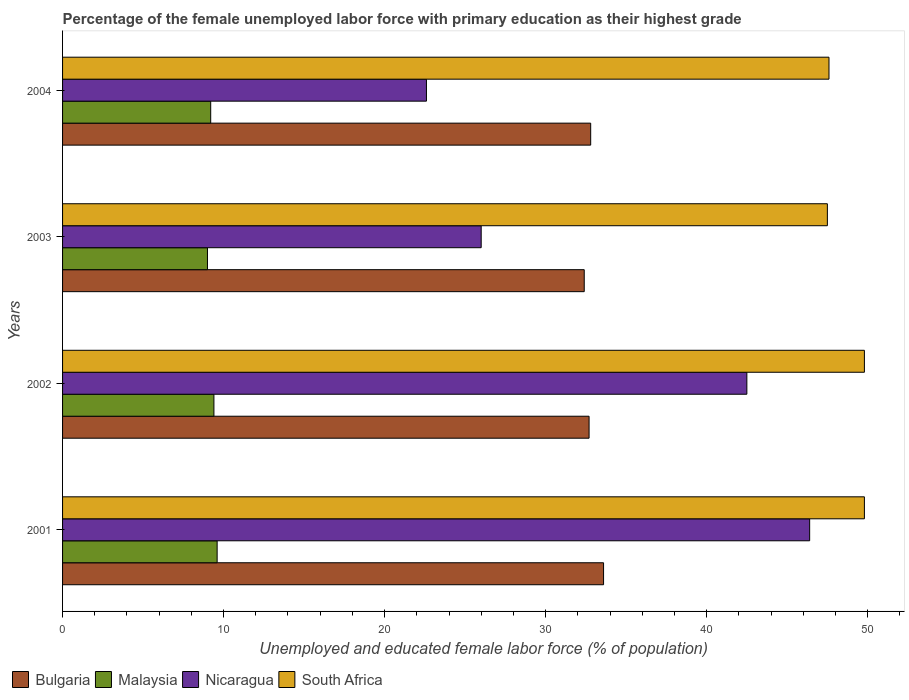How many different coloured bars are there?
Give a very brief answer. 4. How many groups of bars are there?
Offer a very short reply. 4. Are the number of bars per tick equal to the number of legend labels?
Offer a very short reply. Yes. Are the number of bars on each tick of the Y-axis equal?
Ensure brevity in your answer.  Yes. How many bars are there on the 2nd tick from the top?
Offer a very short reply. 4. How many bars are there on the 2nd tick from the bottom?
Your answer should be very brief. 4. In how many cases, is the number of bars for a given year not equal to the number of legend labels?
Provide a succinct answer. 0. What is the percentage of the unemployed female labor force with primary education in Bulgaria in 2004?
Your response must be concise. 32.8. Across all years, what is the maximum percentage of the unemployed female labor force with primary education in Malaysia?
Make the answer very short. 9.6. Across all years, what is the minimum percentage of the unemployed female labor force with primary education in Bulgaria?
Make the answer very short. 32.4. In which year was the percentage of the unemployed female labor force with primary education in Bulgaria maximum?
Offer a very short reply. 2001. In which year was the percentage of the unemployed female labor force with primary education in South Africa minimum?
Keep it short and to the point. 2003. What is the total percentage of the unemployed female labor force with primary education in South Africa in the graph?
Your answer should be very brief. 194.7. What is the difference between the percentage of the unemployed female labor force with primary education in South Africa in 2002 and that in 2004?
Your response must be concise. 2.2. What is the difference between the percentage of the unemployed female labor force with primary education in Bulgaria in 2001 and the percentage of the unemployed female labor force with primary education in Nicaragua in 2003?
Provide a short and direct response. 7.6. What is the average percentage of the unemployed female labor force with primary education in Bulgaria per year?
Provide a succinct answer. 32.88. In the year 2004, what is the difference between the percentage of the unemployed female labor force with primary education in Bulgaria and percentage of the unemployed female labor force with primary education in South Africa?
Provide a short and direct response. -14.8. In how many years, is the percentage of the unemployed female labor force with primary education in Nicaragua greater than 6 %?
Provide a short and direct response. 4. What is the ratio of the percentage of the unemployed female labor force with primary education in Nicaragua in 2001 to that in 2003?
Your answer should be very brief. 1.78. What is the difference between the highest and the second highest percentage of the unemployed female labor force with primary education in Bulgaria?
Your answer should be very brief. 0.8. What is the difference between the highest and the lowest percentage of the unemployed female labor force with primary education in Bulgaria?
Keep it short and to the point. 1.2. Is the sum of the percentage of the unemployed female labor force with primary education in Bulgaria in 2003 and 2004 greater than the maximum percentage of the unemployed female labor force with primary education in South Africa across all years?
Keep it short and to the point. Yes. Is it the case that in every year, the sum of the percentage of the unemployed female labor force with primary education in Bulgaria and percentage of the unemployed female labor force with primary education in Malaysia is greater than the sum of percentage of the unemployed female labor force with primary education in Nicaragua and percentage of the unemployed female labor force with primary education in South Africa?
Offer a very short reply. No. What does the 2nd bar from the bottom in 2004 represents?
Give a very brief answer. Malaysia. Is it the case that in every year, the sum of the percentage of the unemployed female labor force with primary education in Nicaragua and percentage of the unemployed female labor force with primary education in Bulgaria is greater than the percentage of the unemployed female labor force with primary education in Malaysia?
Keep it short and to the point. Yes. Are all the bars in the graph horizontal?
Your response must be concise. Yes. What is the difference between two consecutive major ticks on the X-axis?
Your answer should be compact. 10. How are the legend labels stacked?
Give a very brief answer. Horizontal. What is the title of the graph?
Your answer should be very brief. Percentage of the female unemployed labor force with primary education as their highest grade. What is the label or title of the X-axis?
Provide a short and direct response. Unemployed and educated female labor force (% of population). What is the label or title of the Y-axis?
Offer a very short reply. Years. What is the Unemployed and educated female labor force (% of population) of Bulgaria in 2001?
Ensure brevity in your answer.  33.6. What is the Unemployed and educated female labor force (% of population) in Malaysia in 2001?
Offer a very short reply. 9.6. What is the Unemployed and educated female labor force (% of population) in Nicaragua in 2001?
Provide a short and direct response. 46.4. What is the Unemployed and educated female labor force (% of population) of South Africa in 2001?
Your answer should be compact. 49.8. What is the Unemployed and educated female labor force (% of population) in Bulgaria in 2002?
Provide a short and direct response. 32.7. What is the Unemployed and educated female labor force (% of population) of Malaysia in 2002?
Your answer should be very brief. 9.4. What is the Unemployed and educated female labor force (% of population) in Nicaragua in 2002?
Your answer should be compact. 42.5. What is the Unemployed and educated female labor force (% of population) of South Africa in 2002?
Keep it short and to the point. 49.8. What is the Unemployed and educated female labor force (% of population) of Bulgaria in 2003?
Offer a terse response. 32.4. What is the Unemployed and educated female labor force (% of population) of Malaysia in 2003?
Your answer should be very brief. 9. What is the Unemployed and educated female labor force (% of population) in South Africa in 2003?
Offer a terse response. 47.5. What is the Unemployed and educated female labor force (% of population) in Bulgaria in 2004?
Ensure brevity in your answer.  32.8. What is the Unemployed and educated female labor force (% of population) of Malaysia in 2004?
Your answer should be very brief. 9.2. What is the Unemployed and educated female labor force (% of population) in Nicaragua in 2004?
Offer a very short reply. 22.6. What is the Unemployed and educated female labor force (% of population) in South Africa in 2004?
Give a very brief answer. 47.6. Across all years, what is the maximum Unemployed and educated female labor force (% of population) in Bulgaria?
Offer a very short reply. 33.6. Across all years, what is the maximum Unemployed and educated female labor force (% of population) in Malaysia?
Ensure brevity in your answer.  9.6. Across all years, what is the maximum Unemployed and educated female labor force (% of population) in Nicaragua?
Your response must be concise. 46.4. Across all years, what is the maximum Unemployed and educated female labor force (% of population) in South Africa?
Give a very brief answer. 49.8. Across all years, what is the minimum Unemployed and educated female labor force (% of population) of Bulgaria?
Provide a short and direct response. 32.4. Across all years, what is the minimum Unemployed and educated female labor force (% of population) in Nicaragua?
Make the answer very short. 22.6. Across all years, what is the minimum Unemployed and educated female labor force (% of population) in South Africa?
Keep it short and to the point. 47.5. What is the total Unemployed and educated female labor force (% of population) in Bulgaria in the graph?
Ensure brevity in your answer.  131.5. What is the total Unemployed and educated female labor force (% of population) of Malaysia in the graph?
Your answer should be compact. 37.2. What is the total Unemployed and educated female labor force (% of population) in Nicaragua in the graph?
Offer a very short reply. 137.5. What is the total Unemployed and educated female labor force (% of population) of South Africa in the graph?
Give a very brief answer. 194.7. What is the difference between the Unemployed and educated female labor force (% of population) of Malaysia in 2001 and that in 2002?
Offer a very short reply. 0.2. What is the difference between the Unemployed and educated female labor force (% of population) in Nicaragua in 2001 and that in 2003?
Offer a very short reply. 20.4. What is the difference between the Unemployed and educated female labor force (% of population) in Nicaragua in 2001 and that in 2004?
Your response must be concise. 23.8. What is the difference between the Unemployed and educated female labor force (% of population) of Malaysia in 2002 and that in 2004?
Your response must be concise. 0.2. What is the difference between the Unemployed and educated female labor force (% of population) in Malaysia in 2003 and that in 2004?
Ensure brevity in your answer.  -0.2. What is the difference between the Unemployed and educated female labor force (% of population) in South Africa in 2003 and that in 2004?
Keep it short and to the point. -0.1. What is the difference between the Unemployed and educated female labor force (% of population) of Bulgaria in 2001 and the Unemployed and educated female labor force (% of population) of Malaysia in 2002?
Make the answer very short. 24.2. What is the difference between the Unemployed and educated female labor force (% of population) in Bulgaria in 2001 and the Unemployed and educated female labor force (% of population) in South Africa in 2002?
Provide a succinct answer. -16.2. What is the difference between the Unemployed and educated female labor force (% of population) in Malaysia in 2001 and the Unemployed and educated female labor force (% of population) in Nicaragua in 2002?
Provide a short and direct response. -32.9. What is the difference between the Unemployed and educated female labor force (% of population) in Malaysia in 2001 and the Unemployed and educated female labor force (% of population) in South Africa in 2002?
Your response must be concise. -40.2. What is the difference between the Unemployed and educated female labor force (% of population) of Nicaragua in 2001 and the Unemployed and educated female labor force (% of population) of South Africa in 2002?
Give a very brief answer. -3.4. What is the difference between the Unemployed and educated female labor force (% of population) of Bulgaria in 2001 and the Unemployed and educated female labor force (% of population) of Malaysia in 2003?
Your answer should be very brief. 24.6. What is the difference between the Unemployed and educated female labor force (% of population) of Bulgaria in 2001 and the Unemployed and educated female labor force (% of population) of South Africa in 2003?
Make the answer very short. -13.9. What is the difference between the Unemployed and educated female labor force (% of population) of Malaysia in 2001 and the Unemployed and educated female labor force (% of population) of Nicaragua in 2003?
Provide a short and direct response. -16.4. What is the difference between the Unemployed and educated female labor force (% of population) of Malaysia in 2001 and the Unemployed and educated female labor force (% of population) of South Africa in 2003?
Give a very brief answer. -37.9. What is the difference between the Unemployed and educated female labor force (% of population) of Nicaragua in 2001 and the Unemployed and educated female labor force (% of population) of South Africa in 2003?
Make the answer very short. -1.1. What is the difference between the Unemployed and educated female labor force (% of population) of Bulgaria in 2001 and the Unemployed and educated female labor force (% of population) of Malaysia in 2004?
Provide a short and direct response. 24.4. What is the difference between the Unemployed and educated female labor force (% of population) of Bulgaria in 2001 and the Unemployed and educated female labor force (% of population) of Nicaragua in 2004?
Keep it short and to the point. 11. What is the difference between the Unemployed and educated female labor force (% of population) of Malaysia in 2001 and the Unemployed and educated female labor force (% of population) of South Africa in 2004?
Offer a very short reply. -38. What is the difference between the Unemployed and educated female labor force (% of population) of Nicaragua in 2001 and the Unemployed and educated female labor force (% of population) of South Africa in 2004?
Make the answer very short. -1.2. What is the difference between the Unemployed and educated female labor force (% of population) of Bulgaria in 2002 and the Unemployed and educated female labor force (% of population) of Malaysia in 2003?
Ensure brevity in your answer.  23.7. What is the difference between the Unemployed and educated female labor force (% of population) in Bulgaria in 2002 and the Unemployed and educated female labor force (% of population) in Nicaragua in 2003?
Provide a succinct answer. 6.7. What is the difference between the Unemployed and educated female labor force (% of population) in Bulgaria in 2002 and the Unemployed and educated female labor force (% of population) in South Africa in 2003?
Offer a terse response. -14.8. What is the difference between the Unemployed and educated female labor force (% of population) of Malaysia in 2002 and the Unemployed and educated female labor force (% of population) of Nicaragua in 2003?
Ensure brevity in your answer.  -16.6. What is the difference between the Unemployed and educated female labor force (% of population) in Malaysia in 2002 and the Unemployed and educated female labor force (% of population) in South Africa in 2003?
Provide a succinct answer. -38.1. What is the difference between the Unemployed and educated female labor force (% of population) of Nicaragua in 2002 and the Unemployed and educated female labor force (% of population) of South Africa in 2003?
Your response must be concise. -5. What is the difference between the Unemployed and educated female labor force (% of population) of Bulgaria in 2002 and the Unemployed and educated female labor force (% of population) of Nicaragua in 2004?
Provide a succinct answer. 10.1. What is the difference between the Unemployed and educated female labor force (% of population) of Bulgaria in 2002 and the Unemployed and educated female labor force (% of population) of South Africa in 2004?
Provide a short and direct response. -14.9. What is the difference between the Unemployed and educated female labor force (% of population) of Malaysia in 2002 and the Unemployed and educated female labor force (% of population) of Nicaragua in 2004?
Your answer should be very brief. -13.2. What is the difference between the Unemployed and educated female labor force (% of population) of Malaysia in 2002 and the Unemployed and educated female labor force (% of population) of South Africa in 2004?
Your answer should be very brief. -38.2. What is the difference between the Unemployed and educated female labor force (% of population) of Nicaragua in 2002 and the Unemployed and educated female labor force (% of population) of South Africa in 2004?
Ensure brevity in your answer.  -5.1. What is the difference between the Unemployed and educated female labor force (% of population) of Bulgaria in 2003 and the Unemployed and educated female labor force (% of population) of Malaysia in 2004?
Ensure brevity in your answer.  23.2. What is the difference between the Unemployed and educated female labor force (% of population) of Bulgaria in 2003 and the Unemployed and educated female labor force (% of population) of Nicaragua in 2004?
Give a very brief answer. 9.8. What is the difference between the Unemployed and educated female labor force (% of population) of Bulgaria in 2003 and the Unemployed and educated female labor force (% of population) of South Africa in 2004?
Provide a succinct answer. -15.2. What is the difference between the Unemployed and educated female labor force (% of population) in Malaysia in 2003 and the Unemployed and educated female labor force (% of population) in Nicaragua in 2004?
Your answer should be compact. -13.6. What is the difference between the Unemployed and educated female labor force (% of population) in Malaysia in 2003 and the Unemployed and educated female labor force (% of population) in South Africa in 2004?
Provide a succinct answer. -38.6. What is the difference between the Unemployed and educated female labor force (% of population) of Nicaragua in 2003 and the Unemployed and educated female labor force (% of population) of South Africa in 2004?
Provide a succinct answer. -21.6. What is the average Unemployed and educated female labor force (% of population) of Bulgaria per year?
Offer a very short reply. 32.88. What is the average Unemployed and educated female labor force (% of population) in Nicaragua per year?
Offer a very short reply. 34.38. What is the average Unemployed and educated female labor force (% of population) in South Africa per year?
Offer a terse response. 48.67. In the year 2001, what is the difference between the Unemployed and educated female labor force (% of population) of Bulgaria and Unemployed and educated female labor force (% of population) of Malaysia?
Offer a very short reply. 24. In the year 2001, what is the difference between the Unemployed and educated female labor force (% of population) in Bulgaria and Unemployed and educated female labor force (% of population) in South Africa?
Keep it short and to the point. -16.2. In the year 2001, what is the difference between the Unemployed and educated female labor force (% of population) of Malaysia and Unemployed and educated female labor force (% of population) of Nicaragua?
Ensure brevity in your answer.  -36.8. In the year 2001, what is the difference between the Unemployed and educated female labor force (% of population) in Malaysia and Unemployed and educated female labor force (% of population) in South Africa?
Give a very brief answer. -40.2. In the year 2002, what is the difference between the Unemployed and educated female labor force (% of population) in Bulgaria and Unemployed and educated female labor force (% of population) in Malaysia?
Keep it short and to the point. 23.3. In the year 2002, what is the difference between the Unemployed and educated female labor force (% of population) in Bulgaria and Unemployed and educated female labor force (% of population) in South Africa?
Your answer should be very brief. -17.1. In the year 2002, what is the difference between the Unemployed and educated female labor force (% of population) of Malaysia and Unemployed and educated female labor force (% of population) of Nicaragua?
Keep it short and to the point. -33.1. In the year 2002, what is the difference between the Unemployed and educated female labor force (% of population) in Malaysia and Unemployed and educated female labor force (% of population) in South Africa?
Your answer should be compact. -40.4. In the year 2002, what is the difference between the Unemployed and educated female labor force (% of population) of Nicaragua and Unemployed and educated female labor force (% of population) of South Africa?
Offer a terse response. -7.3. In the year 2003, what is the difference between the Unemployed and educated female labor force (% of population) in Bulgaria and Unemployed and educated female labor force (% of population) in Malaysia?
Your response must be concise. 23.4. In the year 2003, what is the difference between the Unemployed and educated female labor force (% of population) of Bulgaria and Unemployed and educated female labor force (% of population) of Nicaragua?
Offer a terse response. 6.4. In the year 2003, what is the difference between the Unemployed and educated female labor force (% of population) of Bulgaria and Unemployed and educated female labor force (% of population) of South Africa?
Ensure brevity in your answer.  -15.1. In the year 2003, what is the difference between the Unemployed and educated female labor force (% of population) of Malaysia and Unemployed and educated female labor force (% of population) of Nicaragua?
Offer a very short reply. -17. In the year 2003, what is the difference between the Unemployed and educated female labor force (% of population) in Malaysia and Unemployed and educated female labor force (% of population) in South Africa?
Provide a succinct answer. -38.5. In the year 2003, what is the difference between the Unemployed and educated female labor force (% of population) of Nicaragua and Unemployed and educated female labor force (% of population) of South Africa?
Provide a short and direct response. -21.5. In the year 2004, what is the difference between the Unemployed and educated female labor force (% of population) of Bulgaria and Unemployed and educated female labor force (% of population) of Malaysia?
Your answer should be very brief. 23.6. In the year 2004, what is the difference between the Unemployed and educated female labor force (% of population) of Bulgaria and Unemployed and educated female labor force (% of population) of Nicaragua?
Your response must be concise. 10.2. In the year 2004, what is the difference between the Unemployed and educated female labor force (% of population) of Bulgaria and Unemployed and educated female labor force (% of population) of South Africa?
Make the answer very short. -14.8. In the year 2004, what is the difference between the Unemployed and educated female labor force (% of population) of Malaysia and Unemployed and educated female labor force (% of population) of South Africa?
Make the answer very short. -38.4. In the year 2004, what is the difference between the Unemployed and educated female labor force (% of population) in Nicaragua and Unemployed and educated female labor force (% of population) in South Africa?
Give a very brief answer. -25. What is the ratio of the Unemployed and educated female labor force (% of population) of Bulgaria in 2001 to that in 2002?
Provide a short and direct response. 1.03. What is the ratio of the Unemployed and educated female labor force (% of population) in Malaysia in 2001 to that in 2002?
Offer a very short reply. 1.02. What is the ratio of the Unemployed and educated female labor force (% of population) of Nicaragua in 2001 to that in 2002?
Ensure brevity in your answer.  1.09. What is the ratio of the Unemployed and educated female labor force (% of population) of Malaysia in 2001 to that in 2003?
Make the answer very short. 1.07. What is the ratio of the Unemployed and educated female labor force (% of population) in Nicaragua in 2001 to that in 2003?
Keep it short and to the point. 1.78. What is the ratio of the Unemployed and educated female labor force (% of population) of South Africa in 2001 to that in 2003?
Provide a succinct answer. 1.05. What is the ratio of the Unemployed and educated female labor force (% of population) in Bulgaria in 2001 to that in 2004?
Offer a terse response. 1.02. What is the ratio of the Unemployed and educated female labor force (% of population) in Malaysia in 2001 to that in 2004?
Make the answer very short. 1.04. What is the ratio of the Unemployed and educated female labor force (% of population) of Nicaragua in 2001 to that in 2004?
Your response must be concise. 2.05. What is the ratio of the Unemployed and educated female labor force (% of population) in South Africa in 2001 to that in 2004?
Give a very brief answer. 1.05. What is the ratio of the Unemployed and educated female labor force (% of population) of Bulgaria in 2002 to that in 2003?
Your answer should be compact. 1.01. What is the ratio of the Unemployed and educated female labor force (% of population) in Malaysia in 2002 to that in 2003?
Your answer should be very brief. 1.04. What is the ratio of the Unemployed and educated female labor force (% of population) of Nicaragua in 2002 to that in 2003?
Keep it short and to the point. 1.63. What is the ratio of the Unemployed and educated female labor force (% of population) in South Africa in 2002 to that in 2003?
Provide a succinct answer. 1.05. What is the ratio of the Unemployed and educated female labor force (% of population) in Bulgaria in 2002 to that in 2004?
Provide a short and direct response. 1. What is the ratio of the Unemployed and educated female labor force (% of population) of Malaysia in 2002 to that in 2004?
Provide a short and direct response. 1.02. What is the ratio of the Unemployed and educated female labor force (% of population) of Nicaragua in 2002 to that in 2004?
Provide a short and direct response. 1.88. What is the ratio of the Unemployed and educated female labor force (% of population) in South Africa in 2002 to that in 2004?
Offer a terse response. 1.05. What is the ratio of the Unemployed and educated female labor force (% of population) in Bulgaria in 2003 to that in 2004?
Provide a short and direct response. 0.99. What is the ratio of the Unemployed and educated female labor force (% of population) of Malaysia in 2003 to that in 2004?
Provide a short and direct response. 0.98. What is the ratio of the Unemployed and educated female labor force (% of population) in Nicaragua in 2003 to that in 2004?
Your response must be concise. 1.15. What is the difference between the highest and the second highest Unemployed and educated female labor force (% of population) of Bulgaria?
Offer a terse response. 0.8. What is the difference between the highest and the second highest Unemployed and educated female labor force (% of population) of Malaysia?
Provide a short and direct response. 0.2. What is the difference between the highest and the lowest Unemployed and educated female labor force (% of population) in Nicaragua?
Your answer should be very brief. 23.8. 